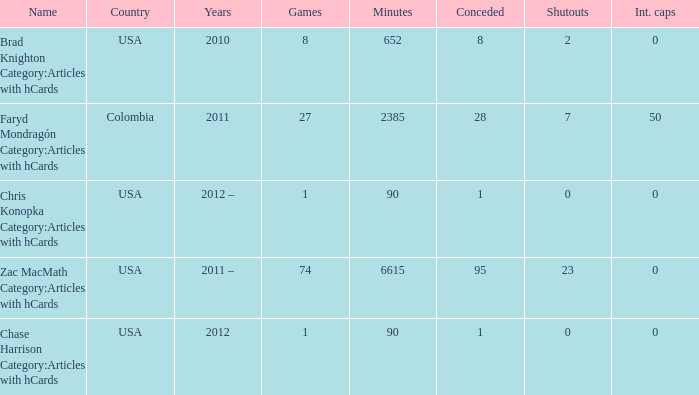When  chris konopka category:articles with hcards is the name what is the year? 2012 –. 